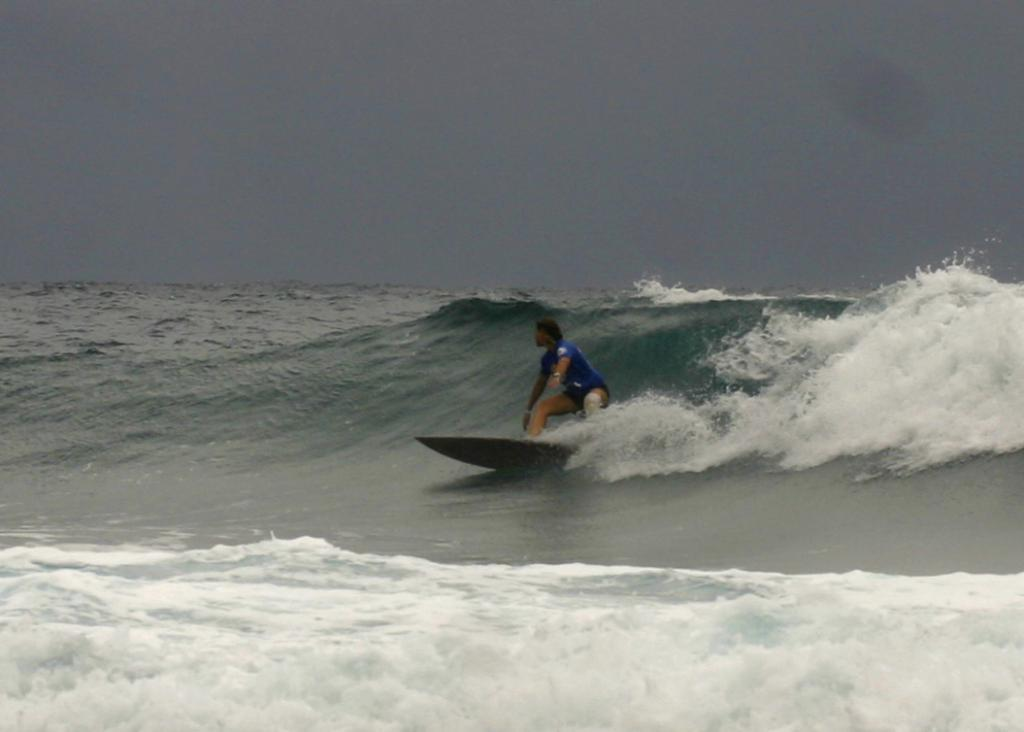Who is the main subject in the image? There is a man in the image. What is the man doing in the image? The man is surfing in the sea. What color is the t-shirt the man is wearing? The man is wearing a blue t-shirt. What is visible at the top of the image? The sky is visible at the top of the image. How much fuel does the man's surfboard require to operate in the image? The man's surfboard does not require fuel to operate, as it is a traditional surfboard powered by the man's movements and the force of the waves. 